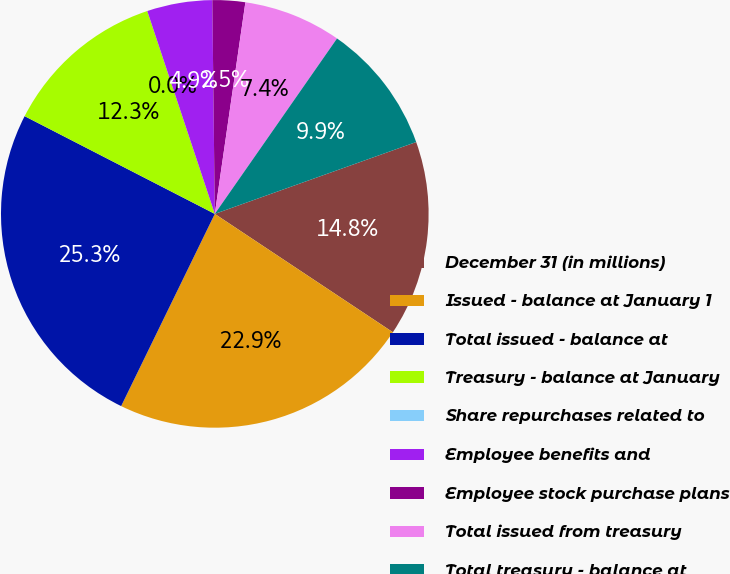Convert chart to OTSL. <chart><loc_0><loc_0><loc_500><loc_500><pie_chart><fcel>December 31 (in millions)<fcel>Issued - balance at January 1<fcel>Total issued - balance at<fcel>Treasury - balance at January<fcel>Share repurchases related to<fcel>Employee benefits and<fcel>Employee stock purchase plans<fcel>Total issued from treasury<fcel>Total treasury - balance at<nl><fcel>14.79%<fcel>22.88%<fcel>25.34%<fcel>12.33%<fcel>0.0%<fcel>4.93%<fcel>2.47%<fcel>7.4%<fcel>9.86%<nl></chart> 